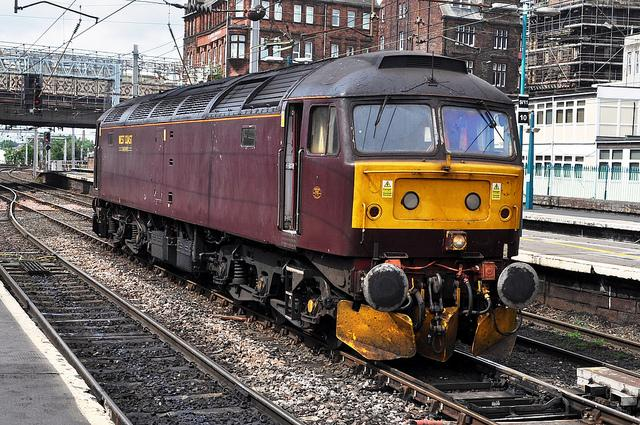What type of area is in the background?

Choices:
A) forest
B) urban
C) rural
D) mountain urban 